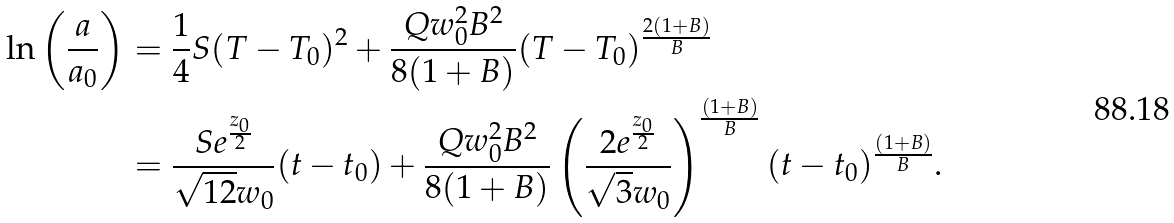Convert formula to latex. <formula><loc_0><loc_0><loc_500><loc_500>\ln \left ( \frac { a } { a _ { 0 } } \right ) & = \frac { 1 } { 4 } S ( T - T _ { 0 } ) ^ { 2 } + \frac { Q w _ { 0 } ^ { 2 } B ^ { 2 } } { 8 ( 1 + B ) } ( T - T _ { 0 } ) ^ { \frac { 2 ( 1 + B ) } { B } } \\ & = \frac { S e ^ { \frac { z _ { 0 } } { 2 } } } { \sqrt { 1 2 } w _ { 0 } } ( t - t _ { 0 } ) + \frac { Q w _ { 0 } ^ { 2 } B ^ { 2 } } { 8 ( 1 + B ) } \left ( \frac { 2 e ^ { \frac { z _ { 0 } } { 2 } } } { \sqrt { 3 } w _ { 0 } } \right ) ^ { \frac { ( 1 + B ) } { B } } ( t - t _ { 0 } ) ^ { \frac { ( 1 + B ) } { B } } .</formula> 